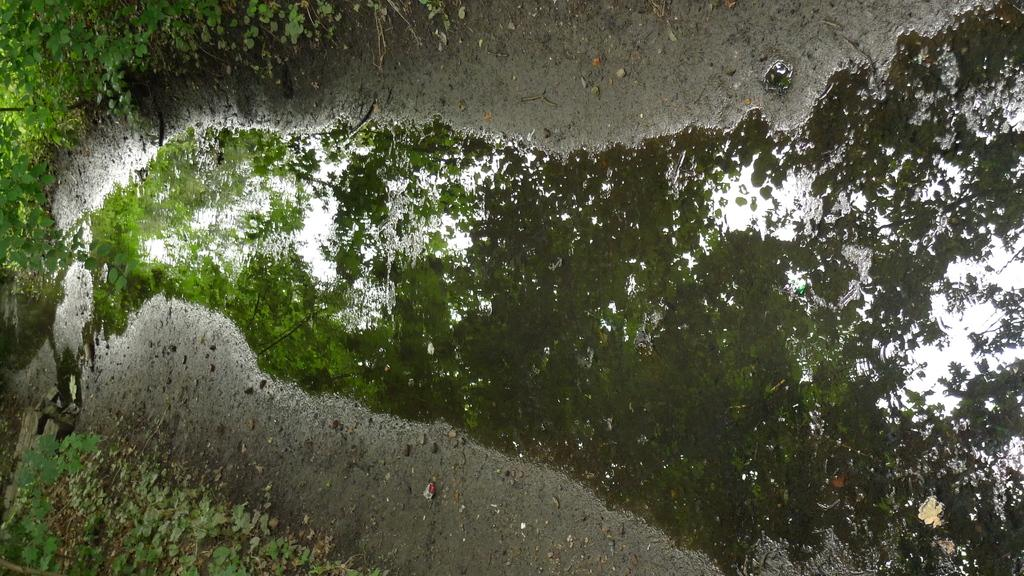What is visible in the image? Water is visible in the image. What can be seen near the water in the image? There are plants near the water in the image. What type of key can be seen floating in the water in the image? There is no key present in the image; it only features water and plants. 